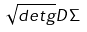Convert formula to latex. <formula><loc_0><loc_0><loc_500><loc_500>\sqrt { d e t g } D \Sigma</formula> 